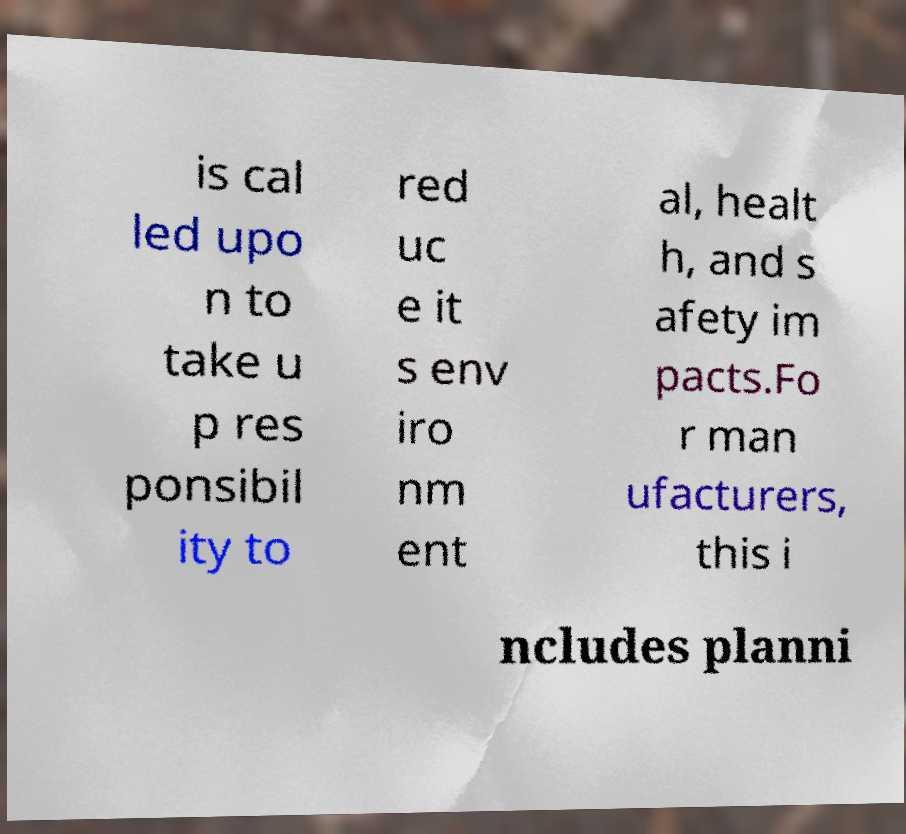Could you assist in decoding the text presented in this image and type it out clearly? is cal led upo n to take u p res ponsibil ity to red uc e it s env iro nm ent al, healt h, and s afety im pacts.Fo r man ufacturers, this i ncludes planni 